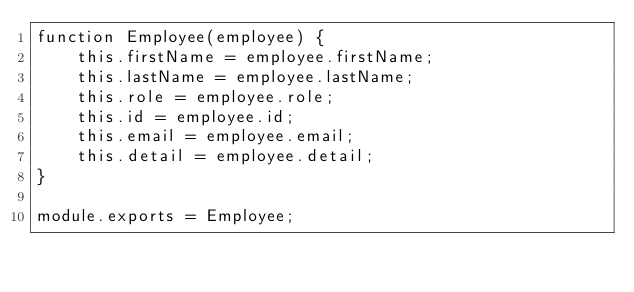Convert code to text. <code><loc_0><loc_0><loc_500><loc_500><_JavaScript_>function Employee(employee) {
    this.firstName = employee.firstName;
    this.lastName = employee.lastName;
    this.role = employee.role;
    this.id = employee.id;
    this.email = employee.email;
    this.detail = employee.detail;
}

module.exports = Employee;</code> 